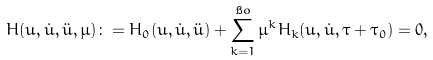<formula> <loc_0><loc_0><loc_500><loc_500>H ( u , \dot { u } , \ddot { u } , \mu ) \colon = H _ { 0 } ( u , \dot { u } , \ddot { u } ) + \sum _ { k = 1 } ^ { \i o } \mu ^ { k } H _ { k } ( u , \dot { u } , \tau + \tau _ { 0 } ) = 0 ,</formula> 